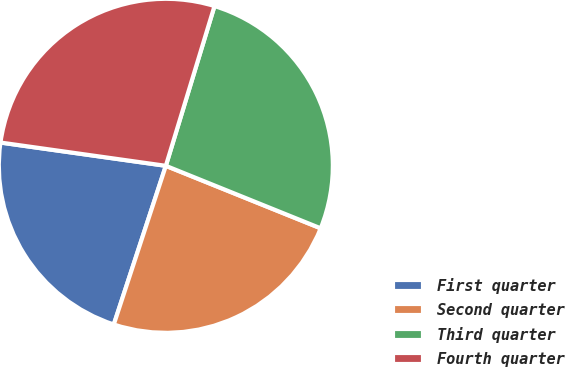Convert chart to OTSL. <chart><loc_0><loc_0><loc_500><loc_500><pie_chart><fcel>First quarter<fcel>Second quarter<fcel>Third quarter<fcel>Fourth quarter<nl><fcel>22.18%<fcel>23.94%<fcel>26.4%<fcel>27.48%<nl></chart> 